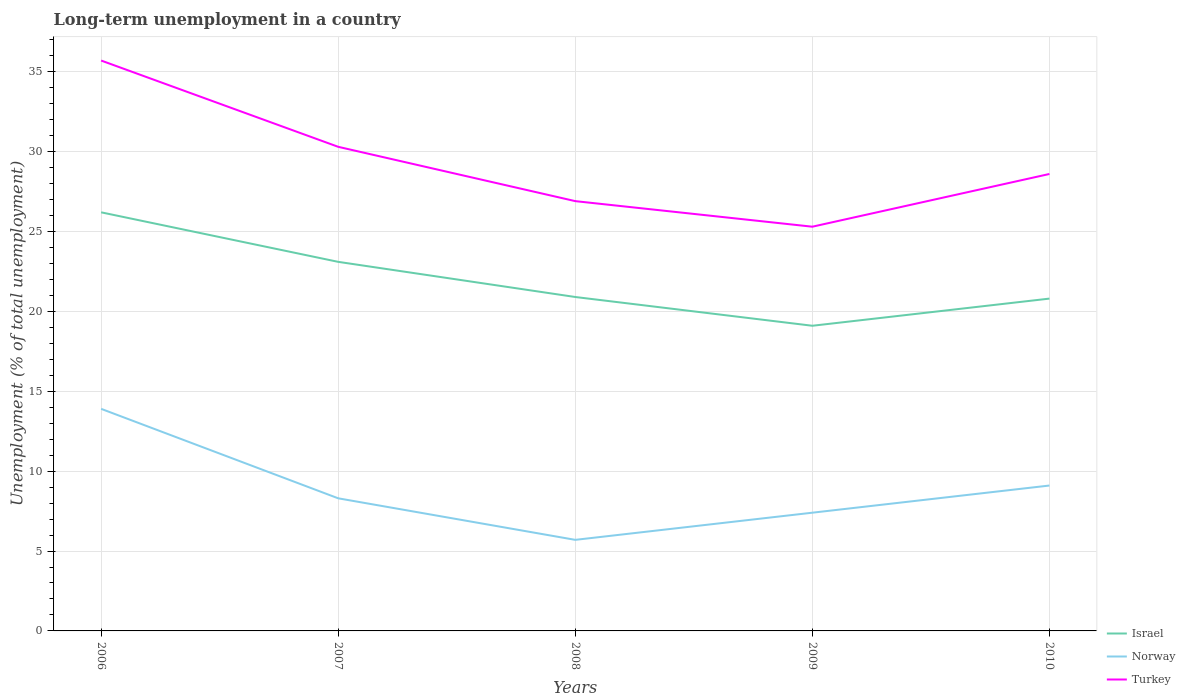How many different coloured lines are there?
Provide a succinct answer. 3. Is the number of lines equal to the number of legend labels?
Your response must be concise. Yes. Across all years, what is the maximum percentage of long-term unemployed population in Turkey?
Your answer should be compact. 25.3. What is the total percentage of long-term unemployed population in Israel in the graph?
Ensure brevity in your answer.  -1.7. What is the difference between the highest and the second highest percentage of long-term unemployed population in Israel?
Keep it short and to the point. 7.1. What is the difference between the highest and the lowest percentage of long-term unemployed population in Israel?
Your answer should be compact. 2. Is the percentage of long-term unemployed population in Turkey strictly greater than the percentage of long-term unemployed population in Norway over the years?
Your answer should be very brief. No. How many lines are there?
Make the answer very short. 3. How many years are there in the graph?
Give a very brief answer. 5. Are the values on the major ticks of Y-axis written in scientific E-notation?
Your answer should be very brief. No. Where does the legend appear in the graph?
Your response must be concise. Bottom right. What is the title of the graph?
Your answer should be compact. Long-term unemployment in a country. Does "High income: nonOECD" appear as one of the legend labels in the graph?
Offer a terse response. No. What is the label or title of the X-axis?
Make the answer very short. Years. What is the label or title of the Y-axis?
Offer a very short reply. Unemployment (% of total unemployment). What is the Unemployment (% of total unemployment) in Israel in 2006?
Offer a terse response. 26.2. What is the Unemployment (% of total unemployment) of Norway in 2006?
Keep it short and to the point. 13.9. What is the Unemployment (% of total unemployment) in Turkey in 2006?
Your answer should be very brief. 35.7. What is the Unemployment (% of total unemployment) in Israel in 2007?
Give a very brief answer. 23.1. What is the Unemployment (% of total unemployment) in Norway in 2007?
Your answer should be compact. 8.3. What is the Unemployment (% of total unemployment) in Turkey in 2007?
Your answer should be very brief. 30.3. What is the Unemployment (% of total unemployment) in Israel in 2008?
Give a very brief answer. 20.9. What is the Unemployment (% of total unemployment) in Norway in 2008?
Your answer should be compact. 5.7. What is the Unemployment (% of total unemployment) in Turkey in 2008?
Offer a very short reply. 26.9. What is the Unemployment (% of total unemployment) of Israel in 2009?
Your answer should be compact. 19.1. What is the Unemployment (% of total unemployment) in Norway in 2009?
Your answer should be very brief. 7.4. What is the Unemployment (% of total unemployment) in Turkey in 2009?
Ensure brevity in your answer.  25.3. What is the Unemployment (% of total unemployment) of Israel in 2010?
Your answer should be compact. 20.8. What is the Unemployment (% of total unemployment) of Norway in 2010?
Provide a succinct answer. 9.1. What is the Unemployment (% of total unemployment) of Turkey in 2010?
Provide a short and direct response. 28.6. Across all years, what is the maximum Unemployment (% of total unemployment) of Israel?
Give a very brief answer. 26.2. Across all years, what is the maximum Unemployment (% of total unemployment) in Norway?
Offer a very short reply. 13.9. Across all years, what is the maximum Unemployment (% of total unemployment) in Turkey?
Your answer should be very brief. 35.7. Across all years, what is the minimum Unemployment (% of total unemployment) in Israel?
Keep it short and to the point. 19.1. Across all years, what is the minimum Unemployment (% of total unemployment) in Norway?
Offer a very short reply. 5.7. Across all years, what is the minimum Unemployment (% of total unemployment) in Turkey?
Provide a short and direct response. 25.3. What is the total Unemployment (% of total unemployment) of Israel in the graph?
Provide a succinct answer. 110.1. What is the total Unemployment (% of total unemployment) of Norway in the graph?
Offer a very short reply. 44.4. What is the total Unemployment (% of total unemployment) of Turkey in the graph?
Provide a short and direct response. 146.8. What is the difference between the Unemployment (% of total unemployment) of Israel in 2006 and that in 2007?
Your answer should be very brief. 3.1. What is the difference between the Unemployment (% of total unemployment) in Norway in 2006 and that in 2008?
Your answer should be compact. 8.2. What is the difference between the Unemployment (% of total unemployment) in Turkey in 2006 and that in 2008?
Give a very brief answer. 8.8. What is the difference between the Unemployment (% of total unemployment) in Turkey in 2006 and that in 2009?
Keep it short and to the point. 10.4. What is the difference between the Unemployment (% of total unemployment) of Norway in 2006 and that in 2010?
Ensure brevity in your answer.  4.8. What is the difference between the Unemployment (% of total unemployment) in Turkey in 2007 and that in 2008?
Give a very brief answer. 3.4. What is the difference between the Unemployment (% of total unemployment) in Israel in 2007 and that in 2009?
Offer a very short reply. 4. What is the difference between the Unemployment (% of total unemployment) in Norway in 2007 and that in 2009?
Provide a short and direct response. 0.9. What is the difference between the Unemployment (% of total unemployment) in Turkey in 2007 and that in 2009?
Provide a succinct answer. 5. What is the difference between the Unemployment (% of total unemployment) in Turkey in 2007 and that in 2010?
Offer a terse response. 1.7. What is the difference between the Unemployment (% of total unemployment) in Israel in 2008 and that in 2009?
Keep it short and to the point. 1.8. What is the difference between the Unemployment (% of total unemployment) of Turkey in 2008 and that in 2009?
Provide a short and direct response. 1.6. What is the difference between the Unemployment (% of total unemployment) of Norway in 2008 and that in 2010?
Ensure brevity in your answer.  -3.4. What is the difference between the Unemployment (% of total unemployment) in Turkey in 2008 and that in 2010?
Keep it short and to the point. -1.7. What is the difference between the Unemployment (% of total unemployment) of Israel in 2009 and that in 2010?
Make the answer very short. -1.7. What is the difference between the Unemployment (% of total unemployment) of Turkey in 2009 and that in 2010?
Provide a succinct answer. -3.3. What is the difference between the Unemployment (% of total unemployment) in Norway in 2006 and the Unemployment (% of total unemployment) in Turkey in 2007?
Ensure brevity in your answer.  -16.4. What is the difference between the Unemployment (% of total unemployment) in Israel in 2006 and the Unemployment (% of total unemployment) in Turkey in 2008?
Ensure brevity in your answer.  -0.7. What is the difference between the Unemployment (% of total unemployment) in Norway in 2006 and the Unemployment (% of total unemployment) in Turkey in 2008?
Provide a short and direct response. -13. What is the difference between the Unemployment (% of total unemployment) in Norway in 2006 and the Unemployment (% of total unemployment) in Turkey in 2009?
Give a very brief answer. -11.4. What is the difference between the Unemployment (% of total unemployment) in Israel in 2006 and the Unemployment (% of total unemployment) in Turkey in 2010?
Your answer should be compact. -2.4. What is the difference between the Unemployment (% of total unemployment) in Norway in 2006 and the Unemployment (% of total unemployment) in Turkey in 2010?
Offer a very short reply. -14.7. What is the difference between the Unemployment (% of total unemployment) of Israel in 2007 and the Unemployment (% of total unemployment) of Norway in 2008?
Make the answer very short. 17.4. What is the difference between the Unemployment (% of total unemployment) in Norway in 2007 and the Unemployment (% of total unemployment) in Turkey in 2008?
Provide a short and direct response. -18.6. What is the difference between the Unemployment (% of total unemployment) in Israel in 2007 and the Unemployment (% of total unemployment) in Norway in 2009?
Offer a terse response. 15.7. What is the difference between the Unemployment (% of total unemployment) of Israel in 2007 and the Unemployment (% of total unemployment) of Turkey in 2009?
Provide a succinct answer. -2.2. What is the difference between the Unemployment (% of total unemployment) in Norway in 2007 and the Unemployment (% of total unemployment) in Turkey in 2009?
Keep it short and to the point. -17. What is the difference between the Unemployment (% of total unemployment) in Israel in 2007 and the Unemployment (% of total unemployment) in Norway in 2010?
Offer a very short reply. 14. What is the difference between the Unemployment (% of total unemployment) of Israel in 2007 and the Unemployment (% of total unemployment) of Turkey in 2010?
Ensure brevity in your answer.  -5.5. What is the difference between the Unemployment (% of total unemployment) of Norway in 2007 and the Unemployment (% of total unemployment) of Turkey in 2010?
Ensure brevity in your answer.  -20.3. What is the difference between the Unemployment (% of total unemployment) of Israel in 2008 and the Unemployment (% of total unemployment) of Norway in 2009?
Keep it short and to the point. 13.5. What is the difference between the Unemployment (% of total unemployment) in Norway in 2008 and the Unemployment (% of total unemployment) in Turkey in 2009?
Ensure brevity in your answer.  -19.6. What is the difference between the Unemployment (% of total unemployment) of Norway in 2008 and the Unemployment (% of total unemployment) of Turkey in 2010?
Your response must be concise. -22.9. What is the difference between the Unemployment (% of total unemployment) in Israel in 2009 and the Unemployment (% of total unemployment) in Norway in 2010?
Offer a very short reply. 10. What is the difference between the Unemployment (% of total unemployment) of Norway in 2009 and the Unemployment (% of total unemployment) of Turkey in 2010?
Your response must be concise. -21.2. What is the average Unemployment (% of total unemployment) in Israel per year?
Ensure brevity in your answer.  22.02. What is the average Unemployment (% of total unemployment) of Norway per year?
Offer a terse response. 8.88. What is the average Unemployment (% of total unemployment) in Turkey per year?
Provide a short and direct response. 29.36. In the year 2006, what is the difference between the Unemployment (% of total unemployment) of Israel and Unemployment (% of total unemployment) of Turkey?
Provide a short and direct response. -9.5. In the year 2006, what is the difference between the Unemployment (% of total unemployment) in Norway and Unemployment (% of total unemployment) in Turkey?
Your answer should be compact. -21.8. In the year 2008, what is the difference between the Unemployment (% of total unemployment) in Norway and Unemployment (% of total unemployment) in Turkey?
Your answer should be compact. -21.2. In the year 2009, what is the difference between the Unemployment (% of total unemployment) of Norway and Unemployment (% of total unemployment) of Turkey?
Ensure brevity in your answer.  -17.9. In the year 2010, what is the difference between the Unemployment (% of total unemployment) in Israel and Unemployment (% of total unemployment) in Norway?
Provide a short and direct response. 11.7. In the year 2010, what is the difference between the Unemployment (% of total unemployment) in Norway and Unemployment (% of total unemployment) in Turkey?
Ensure brevity in your answer.  -19.5. What is the ratio of the Unemployment (% of total unemployment) of Israel in 2006 to that in 2007?
Offer a terse response. 1.13. What is the ratio of the Unemployment (% of total unemployment) in Norway in 2006 to that in 2007?
Offer a terse response. 1.67. What is the ratio of the Unemployment (% of total unemployment) of Turkey in 2006 to that in 2007?
Make the answer very short. 1.18. What is the ratio of the Unemployment (% of total unemployment) in Israel in 2006 to that in 2008?
Your response must be concise. 1.25. What is the ratio of the Unemployment (% of total unemployment) of Norway in 2006 to that in 2008?
Keep it short and to the point. 2.44. What is the ratio of the Unemployment (% of total unemployment) of Turkey in 2006 to that in 2008?
Provide a short and direct response. 1.33. What is the ratio of the Unemployment (% of total unemployment) in Israel in 2006 to that in 2009?
Provide a succinct answer. 1.37. What is the ratio of the Unemployment (% of total unemployment) of Norway in 2006 to that in 2009?
Ensure brevity in your answer.  1.88. What is the ratio of the Unemployment (% of total unemployment) of Turkey in 2006 to that in 2009?
Offer a very short reply. 1.41. What is the ratio of the Unemployment (% of total unemployment) in Israel in 2006 to that in 2010?
Your answer should be compact. 1.26. What is the ratio of the Unemployment (% of total unemployment) in Norway in 2006 to that in 2010?
Ensure brevity in your answer.  1.53. What is the ratio of the Unemployment (% of total unemployment) in Turkey in 2006 to that in 2010?
Offer a terse response. 1.25. What is the ratio of the Unemployment (% of total unemployment) in Israel in 2007 to that in 2008?
Your answer should be compact. 1.11. What is the ratio of the Unemployment (% of total unemployment) of Norway in 2007 to that in 2008?
Give a very brief answer. 1.46. What is the ratio of the Unemployment (% of total unemployment) in Turkey in 2007 to that in 2008?
Keep it short and to the point. 1.13. What is the ratio of the Unemployment (% of total unemployment) of Israel in 2007 to that in 2009?
Offer a terse response. 1.21. What is the ratio of the Unemployment (% of total unemployment) in Norway in 2007 to that in 2009?
Your answer should be very brief. 1.12. What is the ratio of the Unemployment (% of total unemployment) of Turkey in 2007 to that in 2009?
Offer a very short reply. 1.2. What is the ratio of the Unemployment (% of total unemployment) in Israel in 2007 to that in 2010?
Offer a very short reply. 1.11. What is the ratio of the Unemployment (% of total unemployment) in Norway in 2007 to that in 2010?
Ensure brevity in your answer.  0.91. What is the ratio of the Unemployment (% of total unemployment) of Turkey in 2007 to that in 2010?
Your answer should be compact. 1.06. What is the ratio of the Unemployment (% of total unemployment) of Israel in 2008 to that in 2009?
Make the answer very short. 1.09. What is the ratio of the Unemployment (% of total unemployment) in Norway in 2008 to that in 2009?
Your answer should be very brief. 0.77. What is the ratio of the Unemployment (% of total unemployment) in Turkey in 2008 to that in 2009?
Offer a terse response. 1.06. What is the ratio of the Unemployment (% of total unemployment) in Norway in 2008 to that in 2010?
Offer a terse response. 0.63. What is the ratio of the Unemployment (% of total unemployment) in Turkey in 2008 to that in 2010?
Your answer should be very brief. 0.94. What is the ratio of the Unemployment (% of total unemployment) of Israel in 2009 to that in 2010?
Give a very brief answer. 0.92. What is the ratio of the Unemployment (% of total unemployment) of Norway in 2009 to that in 2010?
Your answer should be very brief. 0.81. What is the ratio of the Unemployment (% of total unemployment) of Turkey in 2009 to that in 2010?
Your response must be concise. 0.88. What is the difference between the highest and the second highest Unemployment (% of total unemployment) in Norway?
Provide a short and direct response. 4.8. What is the difference between the highest and the lowest Unemployment (% of total unemployment) of Turkey?
Provide a succinct answer. 10.4. 